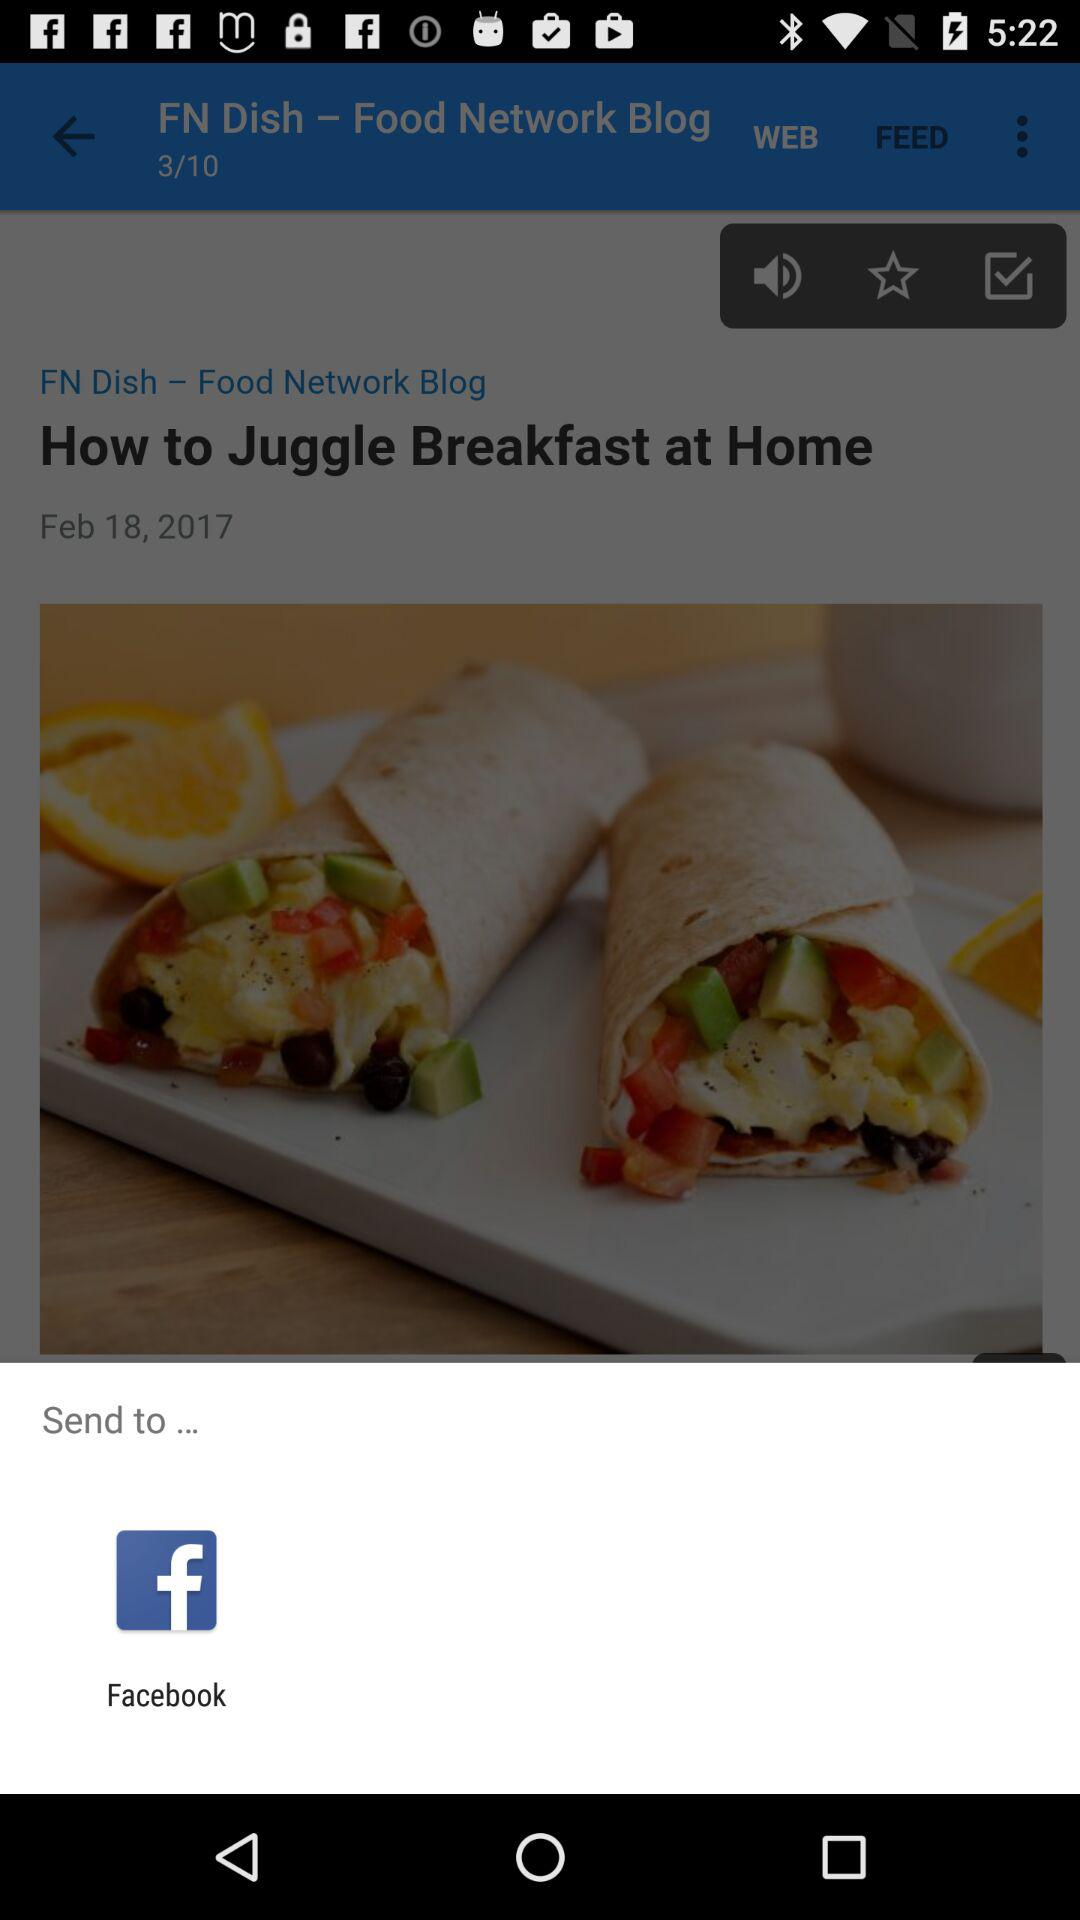What is the total number of pages? The total number of pages is 10. 